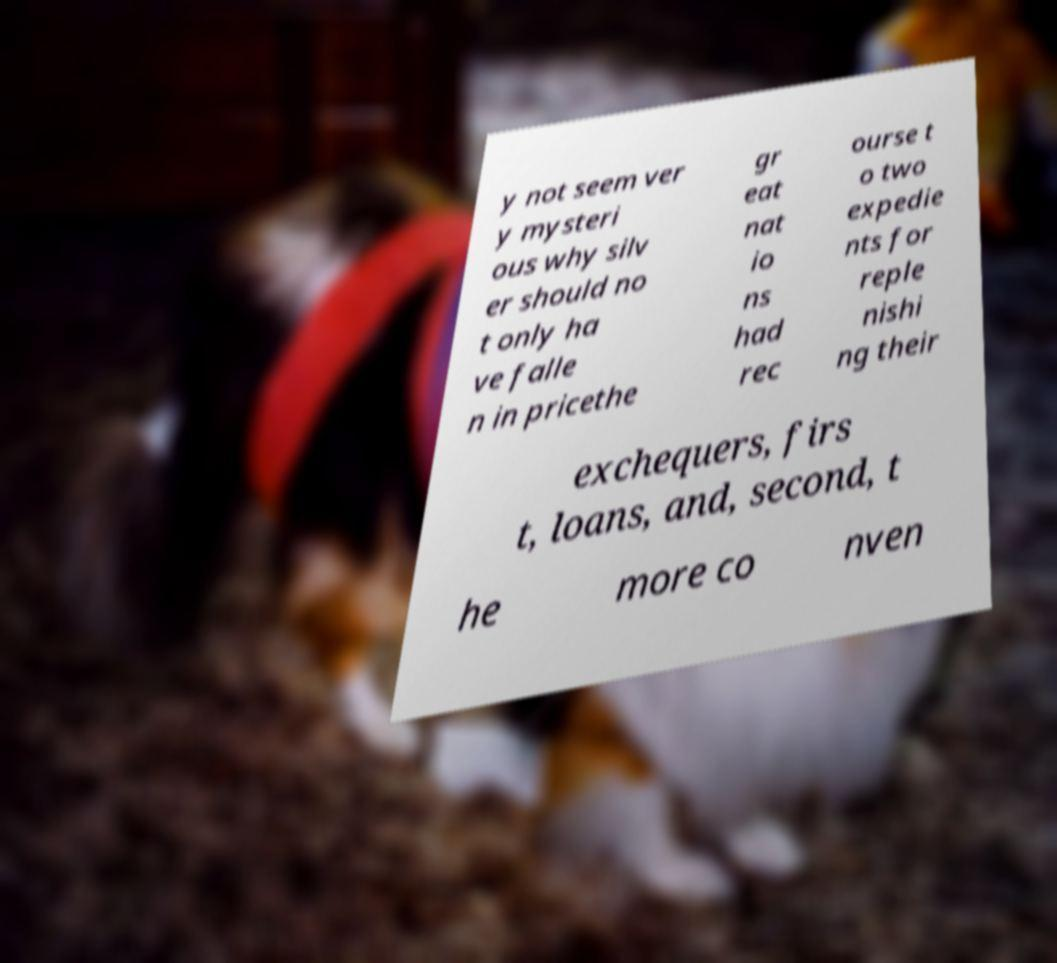Could you extract and type out the text from this image? y not seem ver y mysteri ous why silv er should no t only ha ve falle n in pricethe gr eat nat io ns had rec ourse t o two expedie nts for reple nishi ng their exchequers, firs t, loans, and, second, t he more co nven 